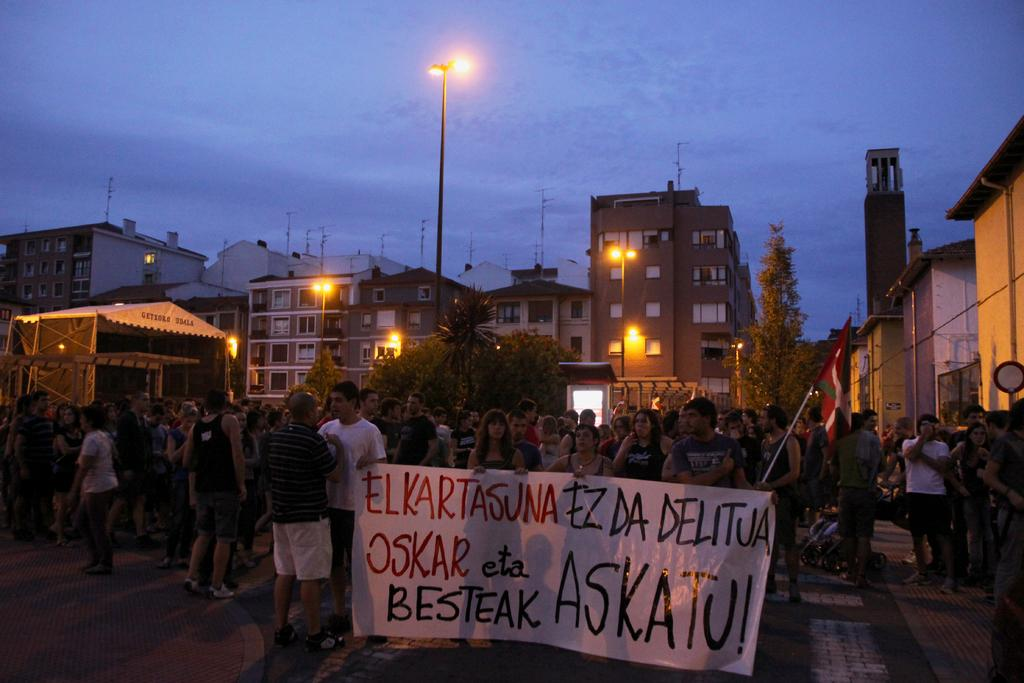What type of structures can be seen in the image? There are buildings in the image. What are the people in the image doing? The people are standing and holding a banner in the image. What other objects can be seen in the image? There is a flag and pole lights in the image. What type of vegetation is present in the image? There are trees in the image. How would you describe the sky in the image? The sky is blue and cloudy in the image. What type of dress is the person wearing in the image? There is no specific dress mentioned in the image; the people are holding a banner. Is there any snow or indication of winter in the image? No, there is no mention of snow or winter in the image. 